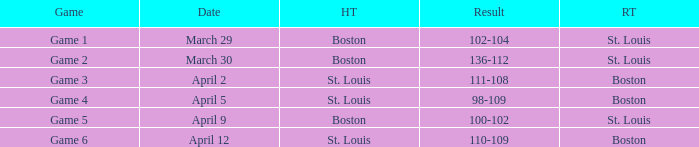Can you tell me the game's result that took place on april 9? 100-102. 